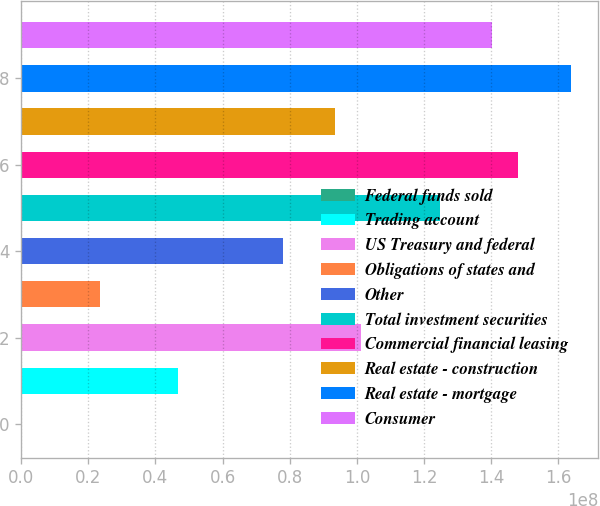Convert chart. <chart><loc_0><loc_0><loc_500><loc_500><bar_chart><fcel>Federal funds sold<fcel>Trading account<fcel>US Treasury and federal<fcel>Obligations of states and<fcel>Other<fcel>Total investment securities<fcel>Commercial financial leasing<fcel>Real estate - construction<fcel>Real estate - mortgage<fcel>Consumer<nl><fcel>2850<fcel>4.67557e+07<fcel>1.01301e+08<fcel>2.33793e+07<fcel>7.79243e+07<fcel>1.24677e+08<fcel>1.48054e+08<fcel>9.35086e+07<fcel>1.63638e+08<fcel>1.40261e+08<nl></chart> 